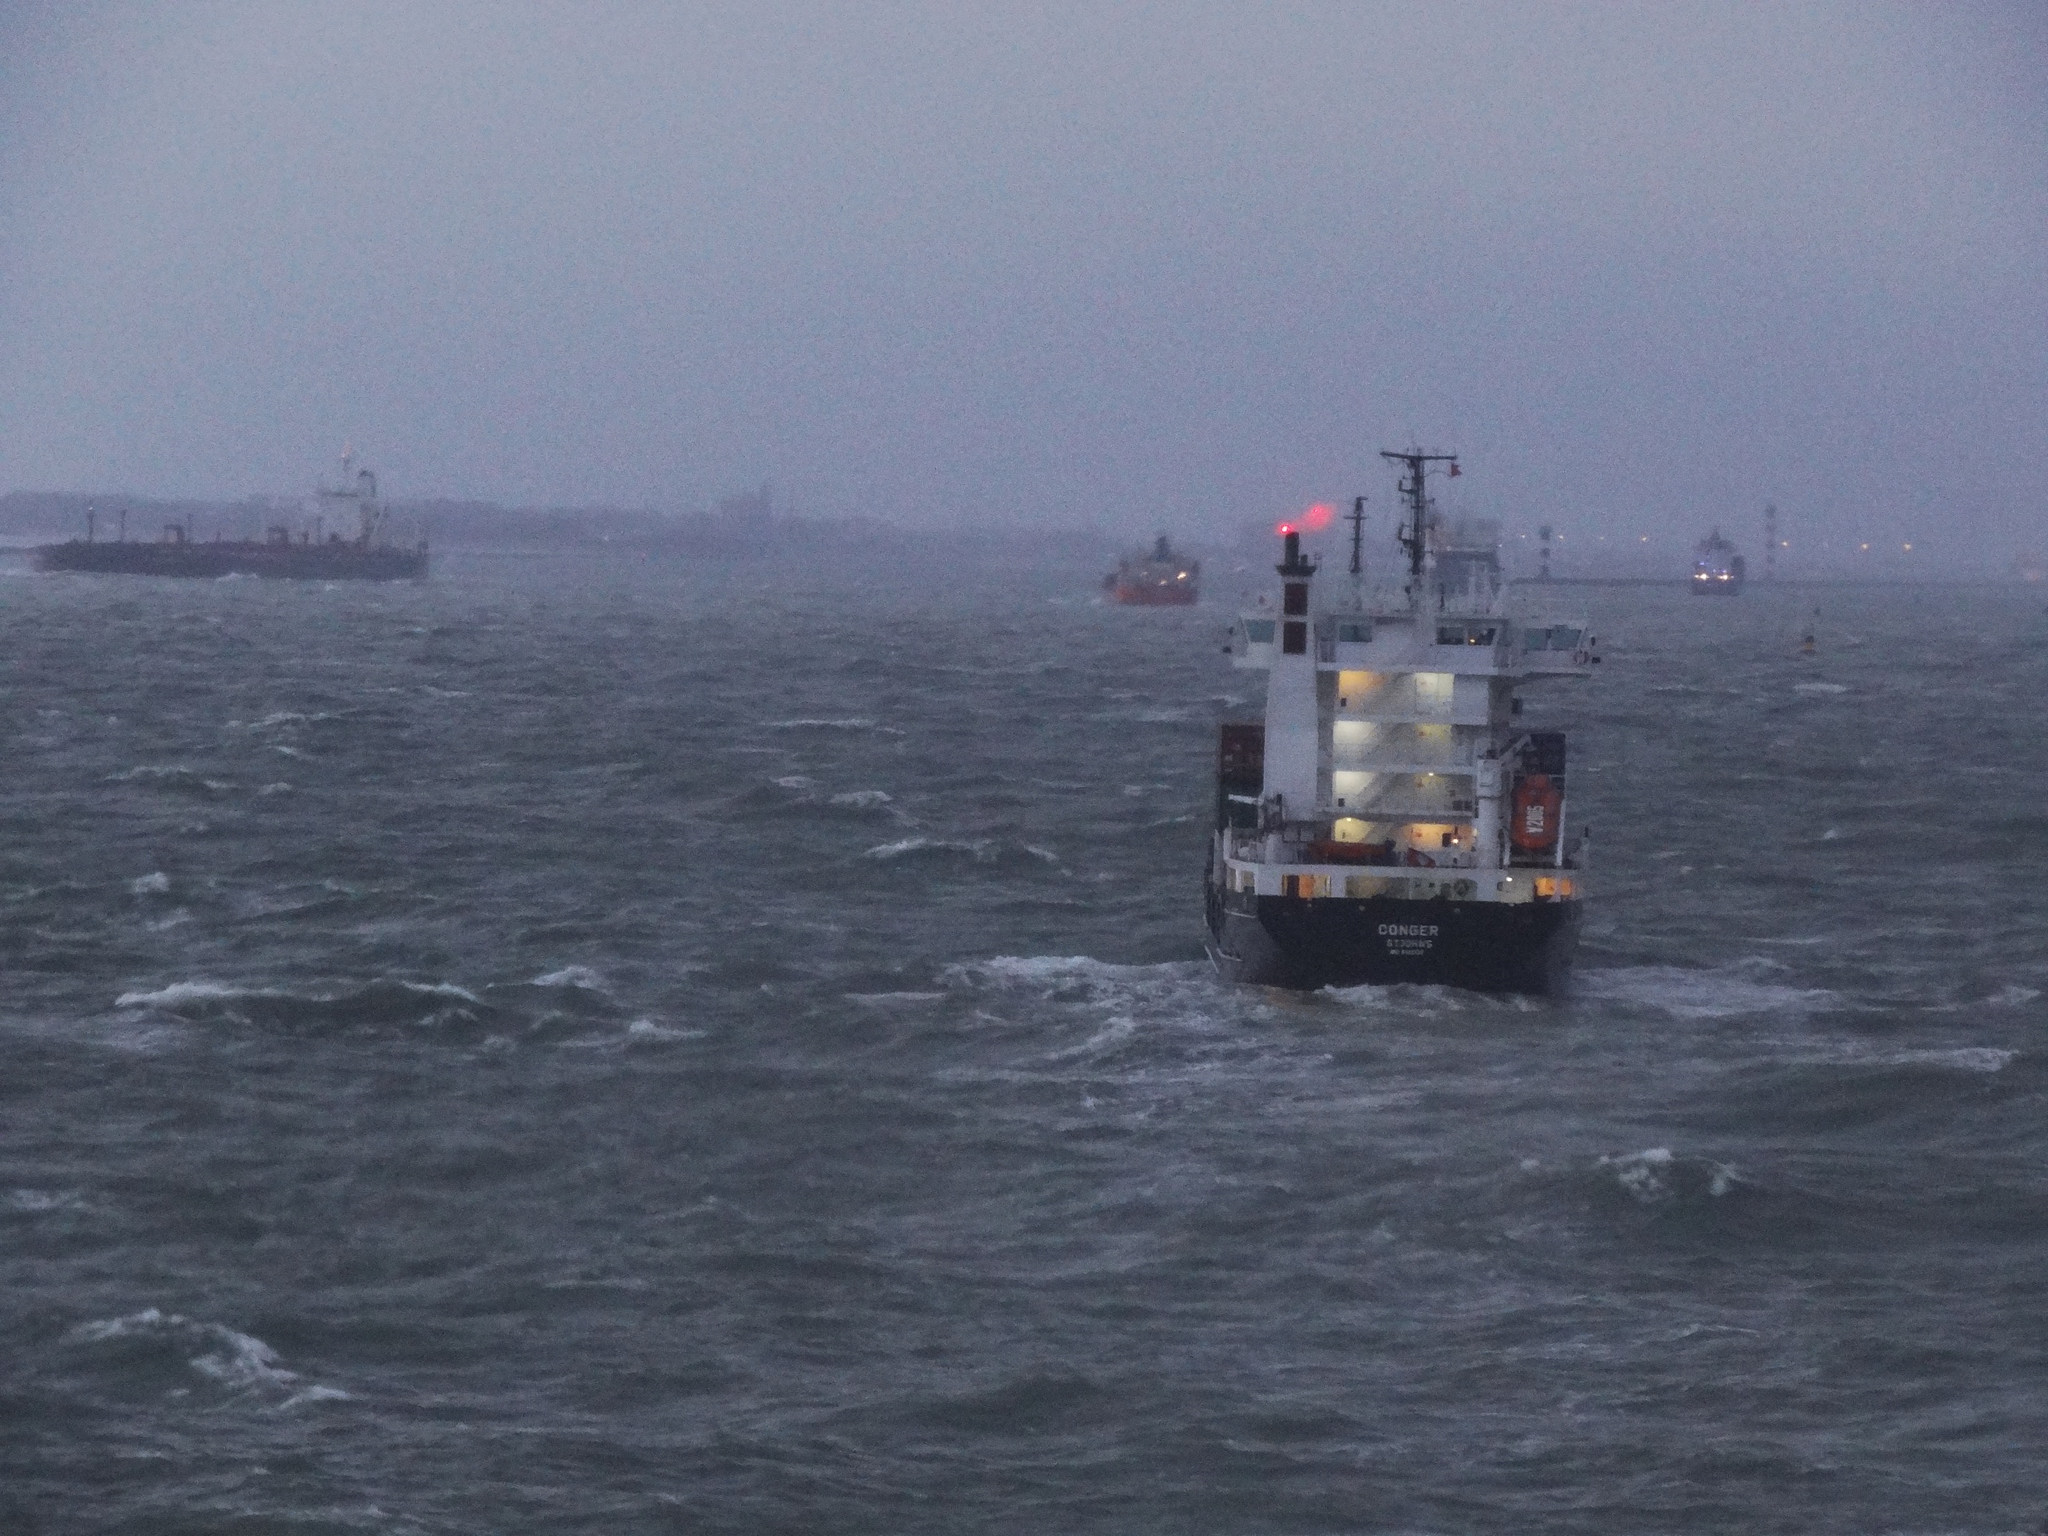Describe this image in one or two sentences. In this image, we can see ships are above the water. Here we can see lights and poles. Background there is a sky. 